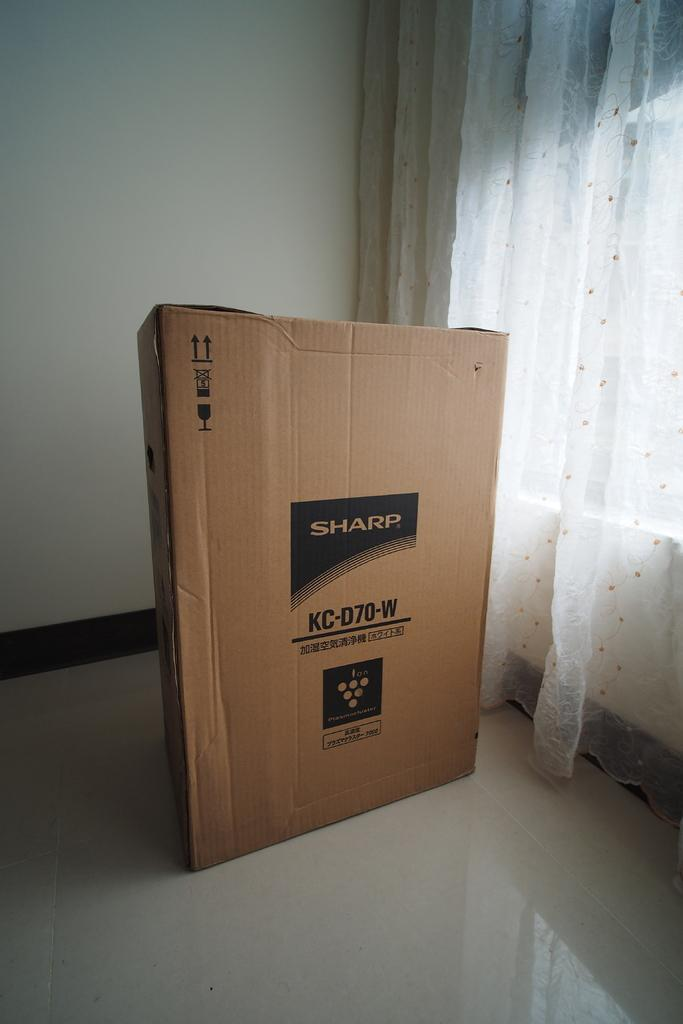<image>
Write a terse but informative summary of the picture. A box for a Sharp KC-D70-W is stood up on the floor near a window. 